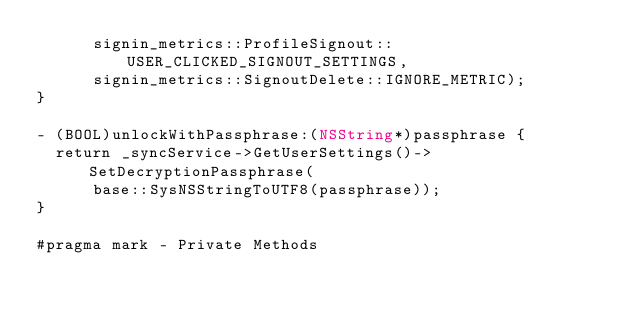Convert code to text. <code><loc_0><loc_0><loc_500><loc_500><_ObjectiveC_>      signin_metrics::ProfileSignout::USER_CLICKED_SIGNOUT_SETTINGS,
      signin_metrics::SignoutDelete::IGNORE_METRIC);
}

- (BOOL)unlockWithPassphrase:(NSString*)passphrase {
  return _syncService->GetUserSettings()->SetDecryptionPassphrase(
      base::SysNSStringToUTF8(passphrase));
}

#pragma mark - Private Methods
</code> 